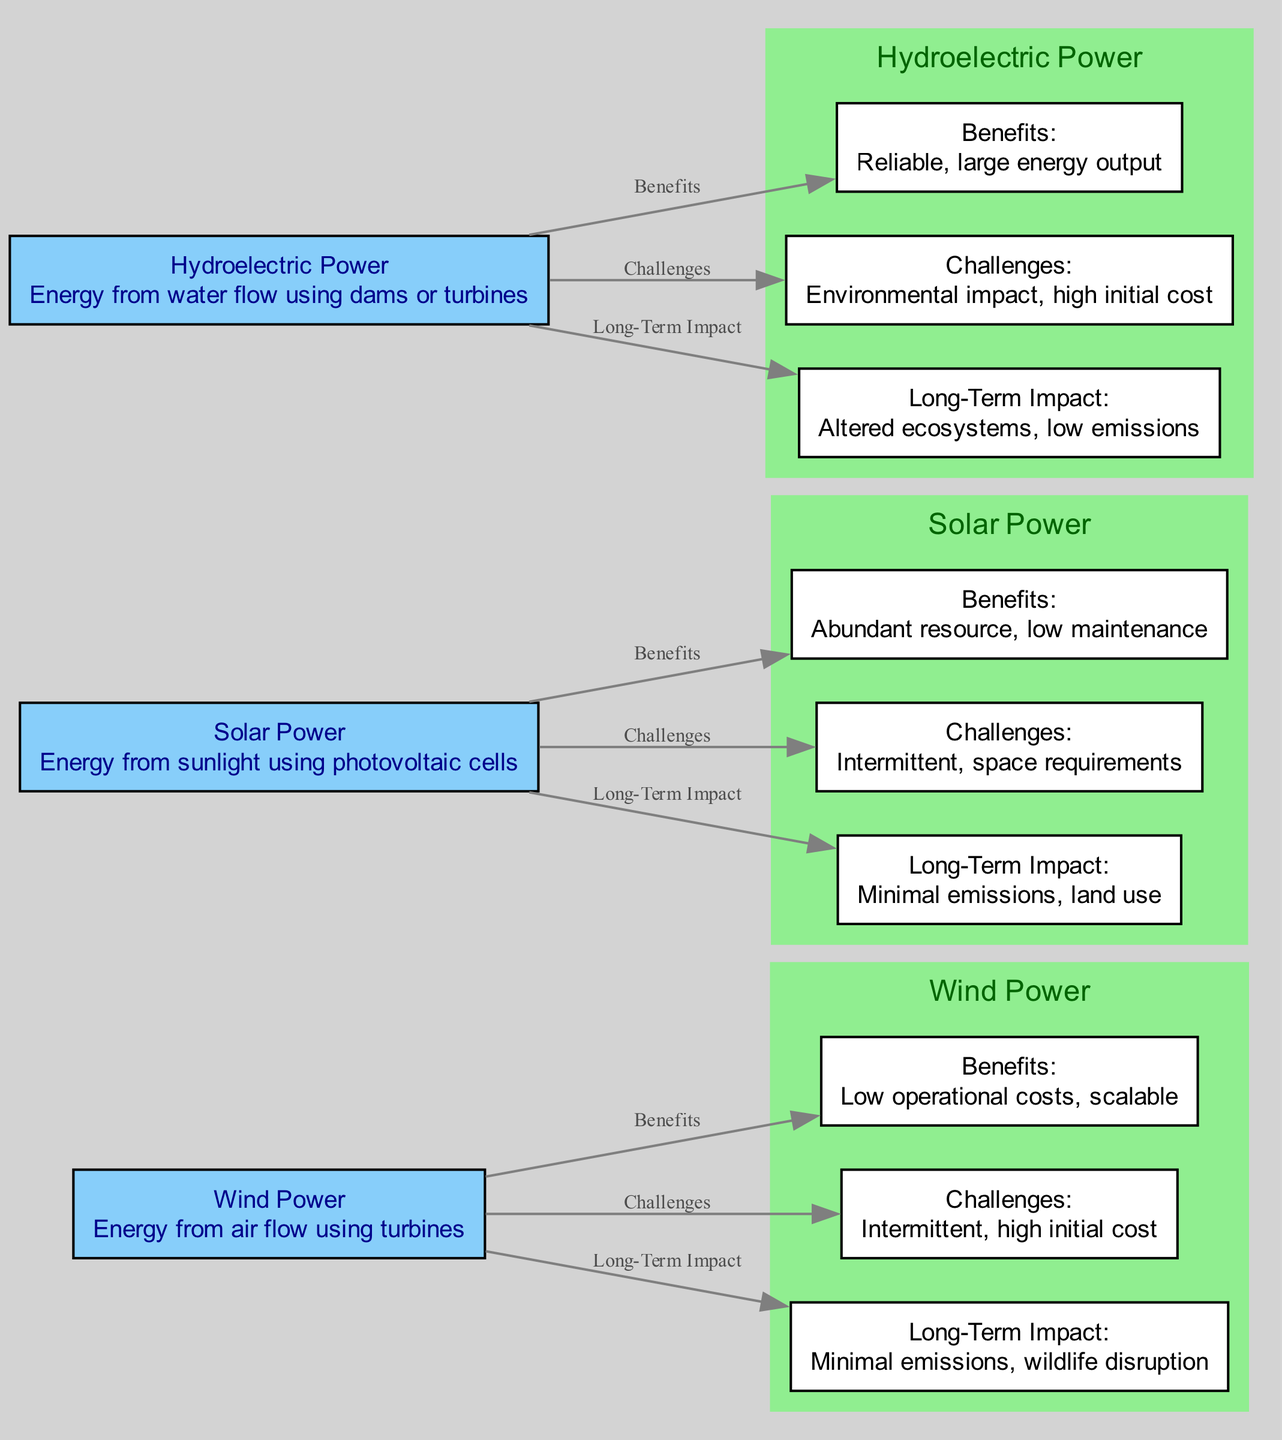What is the primary resource used in Wind Power? The diagram specifies that Wind Power uses energy from air flow, which is harnessed through turbines. This information is directly stated in the details of the Wind Power node.
Answer: air flow How many benefits are listed for Solar Power? The diagram shows one node connected to the Solar Power node labeled "Benefits," indicating there is one benefits entry specifically noted for Solar Power.
Answer: 1 What is a major challenge for Hydroelectric Power? The diagram indicates that Hydroelectric Power faces challenges, specifically noted as "Environmental impact" and "high initial cost." Among these, the mentioned challenge can be identified directly from the node connected to the Hydroelectric Power node under challenges.
Answer: Environmental impact Which renewable energy source has the lowest operational cost according to the benefits? The benefits of Wind Power state "Low operational costs," as detailed in the node that describes the advantages of Wind Energy. This indicates that compared to the others, Wind Power is noted for having lower operational costs.
Answer: Wind Power What is the long-term impact of Solar Power? The diagram specifies that the long-term impact of Solar Power is "Minimal emissions, land use." This is described in the node that connects the Solar Power source to its long-term impacts, describing its effects.
Answer: Minimal emissions, land use Which renewable energy source provides a reliable energy output? Hydroelectric Power is noted for its reliability and large energy output under benefits. This indicates its consistent performance as a renewable energy source.
Answer: Hydroelectric Power What challenge do both Wind and Solar Power share? Both Wind Power and Solar Power have the challenge labeled "Intermittent," which means their energy generation can be inconsistent based on environmental conditions. This shared challenge indicates their dependency on natural factors.
Answer: Intermittent What kind of impact does Hydroelectric Power have on ecosystems? The diagram indicates that Hydroelectric Power alters ecosystems as part of its long-term impact. This information is found in the node that describes the ecological consequences of implementing Hydroelectric systems.
Answer: Altered ecosystems How are the benefits of Wind Power described in the diagram? The benefits of Wind Power node states "Low operational costs, scalable," which directly describes both the financial advantage and the flexibility of scaling Wind Power systems. This concise description outlines the main advantages provided in the diagram.
Answer: Low operational costs, scalable 